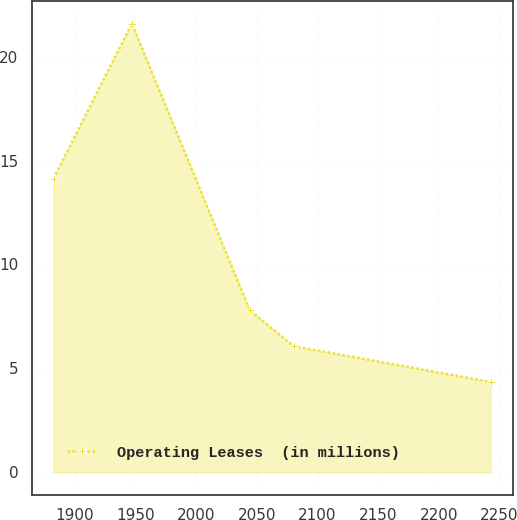Convert chart to OTSL. <chart><loc_0><loc_0><loc_500><loc_500><line_chart><ecel><fcel>Operating Leases  (in millions)<nl><fcel>1882.43<fcel>14.13<nl><fcel>1947.01<fcel>21.59<nl><fcel>2044.2<fcel>7.79<nl><fcel>2080.23<fcel>6.07<nl><fcel>2242.75<fcel>4.35<nl></chart> 